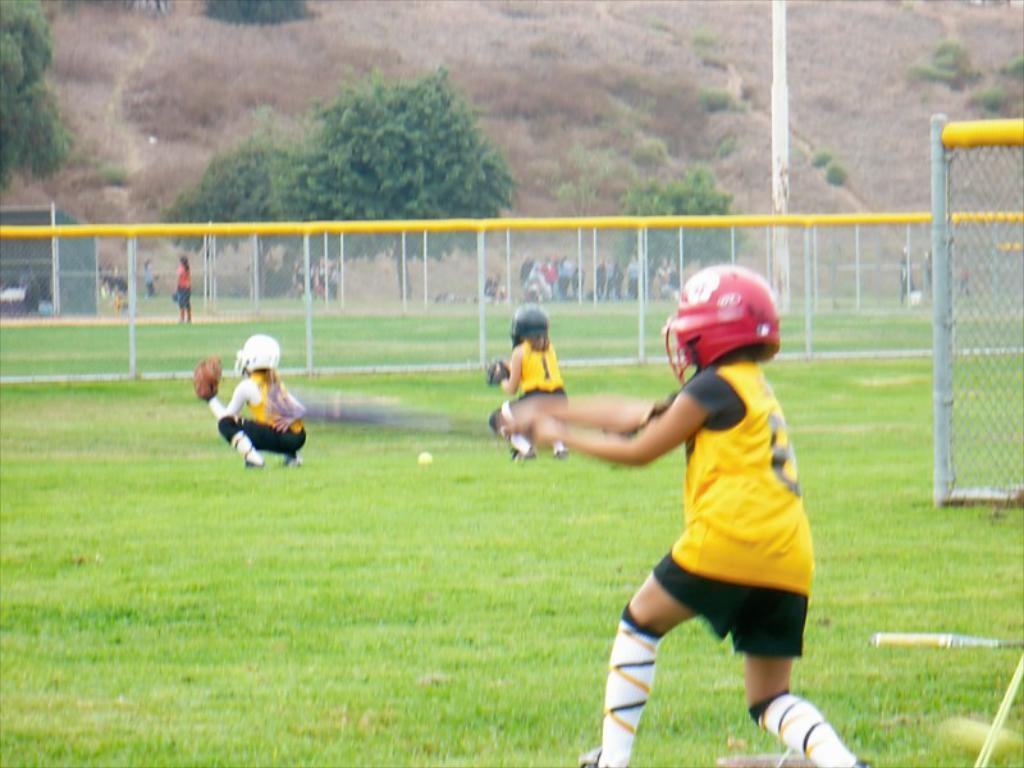Can you describe this image briefly? In this picture there is a person with red helmet is holding the bat and there are two persons squatting. There are group of people standing behind the fence and there are trees and there is a shed and pole. On the right side of the image there is a fence. At the bottom there is a ball and bat on the grass. 